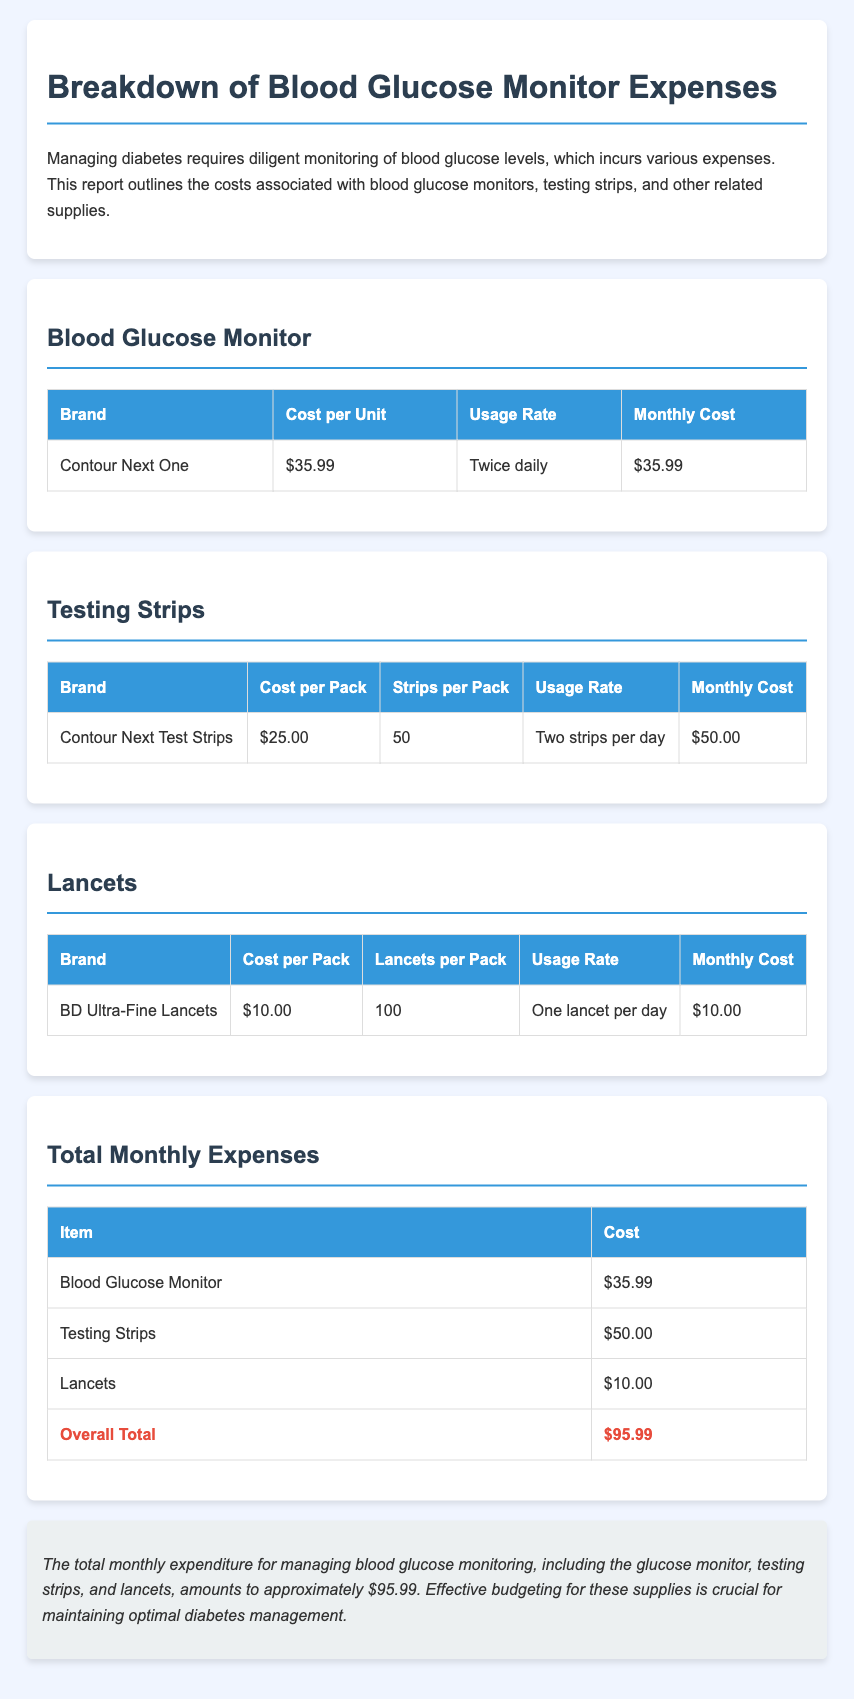What is the cost per unit of the blood glucose monitor? The cost per unit of the blood glucose monitor is mentioned in the table, which is $35.99.
Answer: $35.99 How many testing strips are there per pack? The number of testing strips per pack is provided in the document, which states 50 strips.
Answer: 50 What is the monthly cost for testing strips? The monthly cost for testing strips is calculated from the usage rate and cost per pack, which is $50.00.
Answer: $50.00 What is the total monthly expenditure for managing blood glucose monitoring? The overall total for all items in the report is listed in the total monthly expenses section, which equals $95.99.
Answer: $95.99 How many times a day is the blood glucose monitor used? The usage rate for the blood glucose monitor is indicated as twice daily in the document.
Answer: Twice daily What is the total cost of lancets per month? The total cost for lancets is provided, which is $10.00 per month.
Answer: $10.00 What is the cost per pack of testing strips? The cost per pack of testing strips is stated in the table as $25.00.
Answer: $25.00 How many lancets are in a pack? The document lists the number of lancets in a pack as 100.
Answer: 100 Who is the brand for the blood glucose monitor? The brand for the blood glucose monitor is specified in the report as Contour Next One.
Answer: Contour Next One 